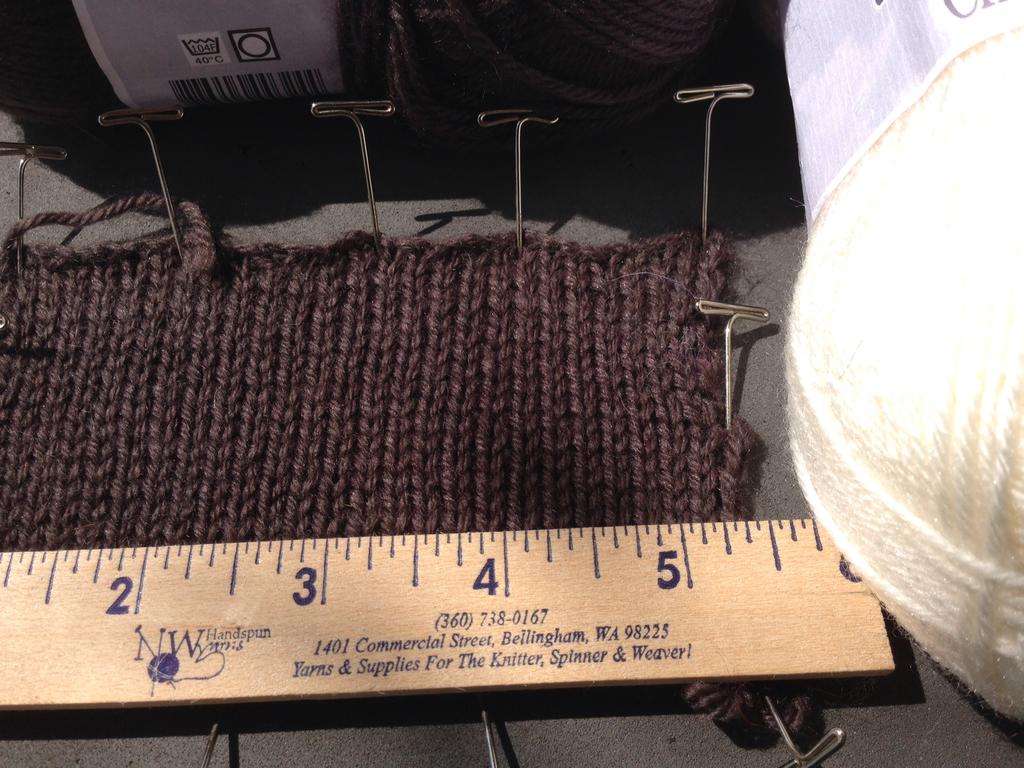What phone number in on the ruler?
Make the answer very short. 360-738-0167. How many inches long is this ruler?
Your answer should be compact. 6. 